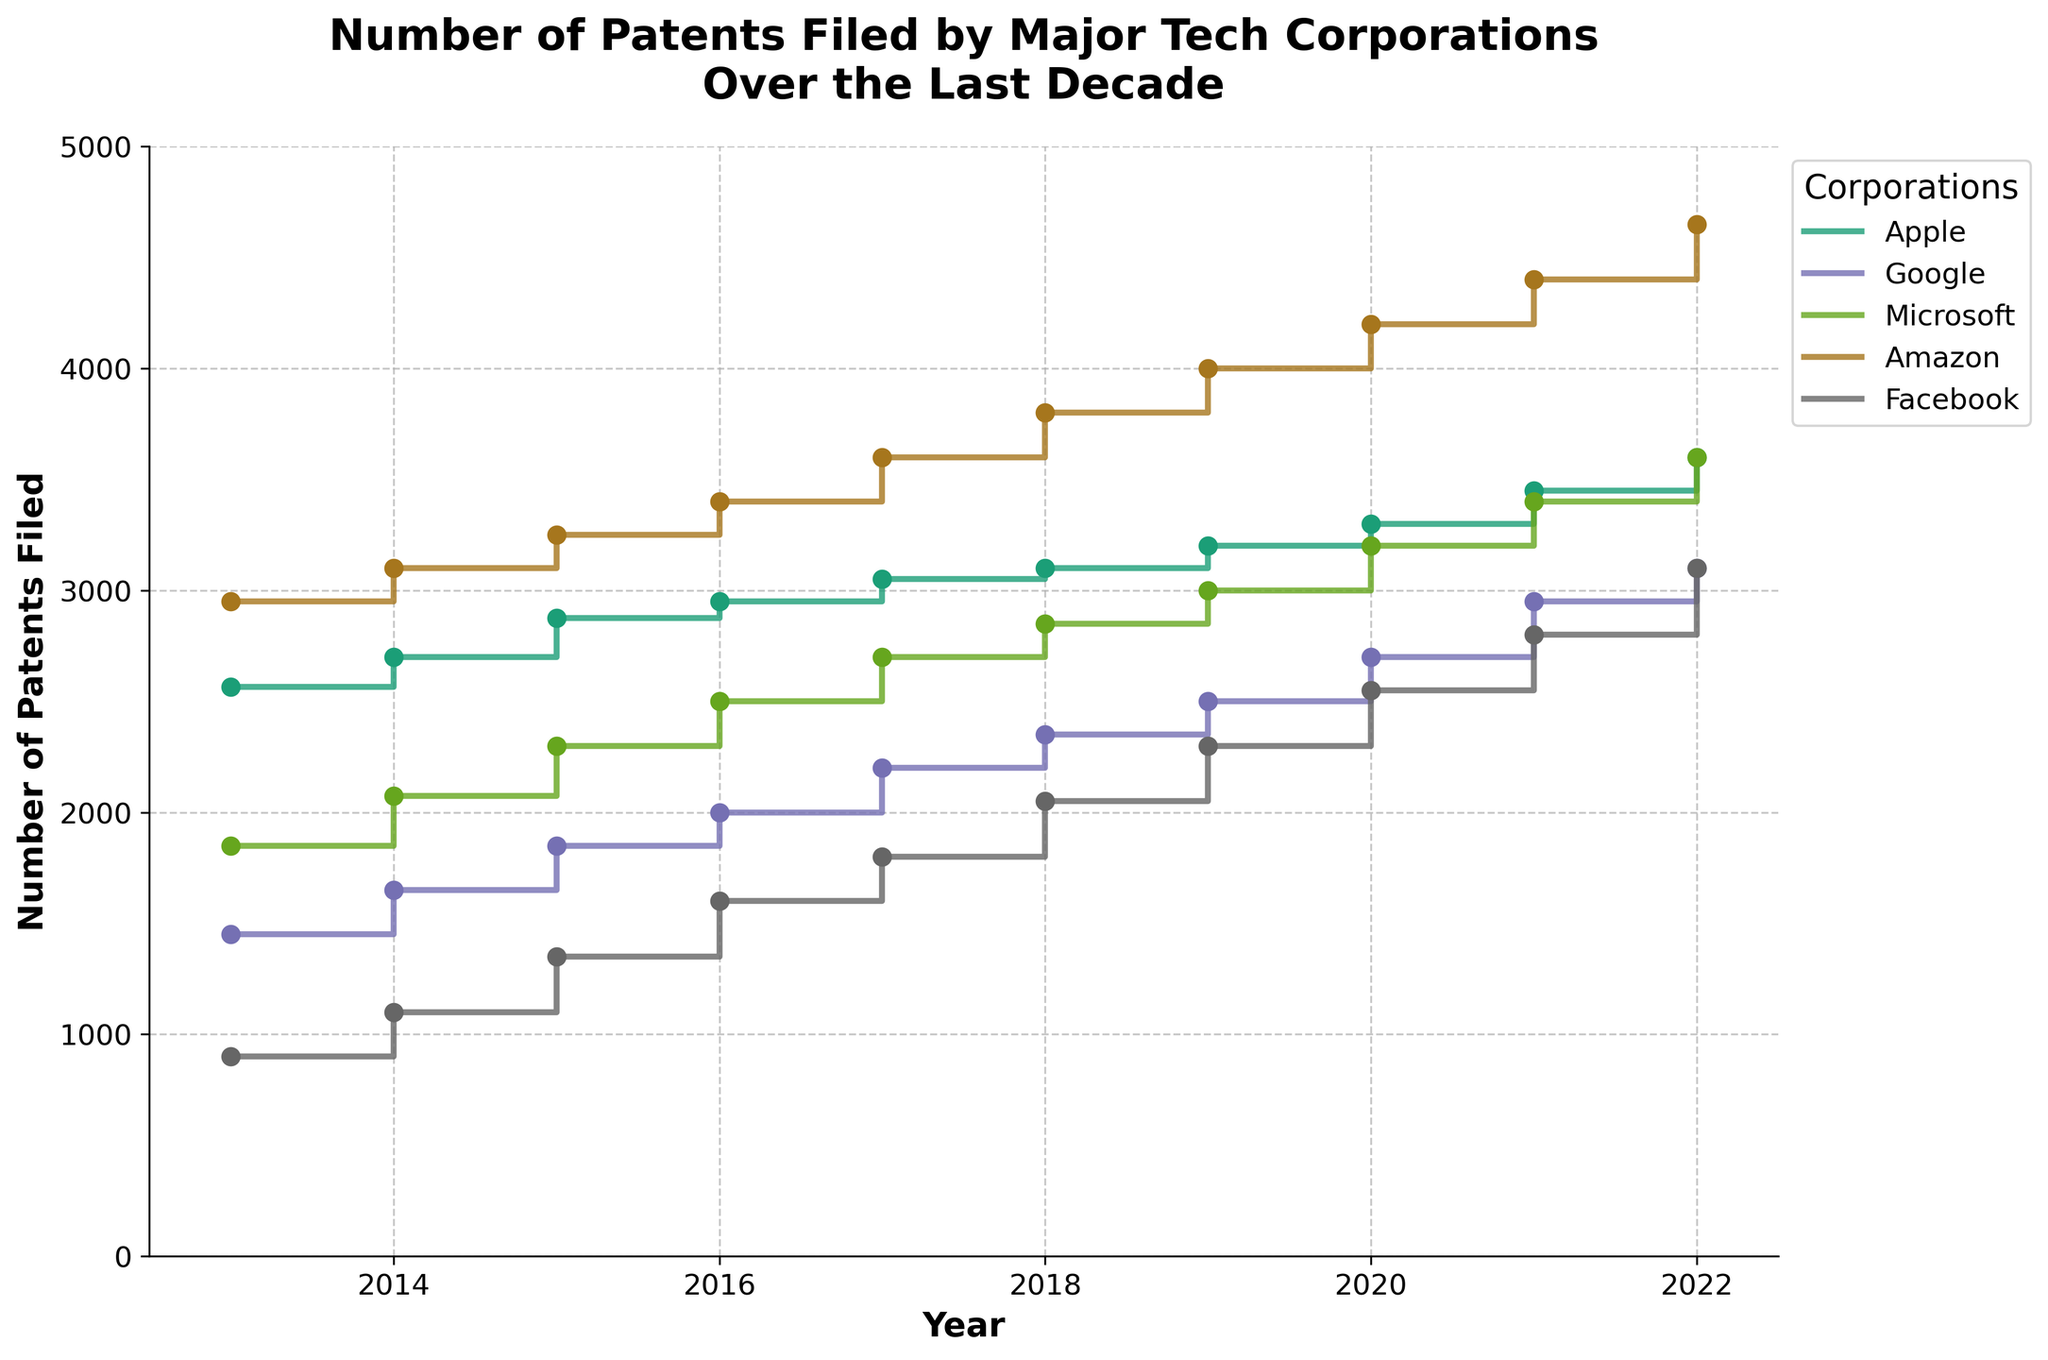What year does the figure start? The figure indicates the patents filed from different corporations starting from the year on the x-axis' lower bound. The axis starts from 2013.
Answer: 2013 Which corporation filed the most patents in 2022? To find this, look at the data points for 2022 and compare the values. Amazon has the highest value at 4650 patents filed.
Answer: Amazon How did the number of patents filed by Facebook change from 2013 to 2022? Check the starting and ending points for Facebook in the plot. Facebook's patents increased from 900 in 2013 to 3100 in 2022.
Answer: Increased Which corporation showed a relatively steady increase in the number of patents filed each year? Look for corporations whose stair steps have relatively uniform height. Google shows a relatively steady increase each year.
Answer: Google In which year did Apple surpass 3000 patents filed? To find when Apple's patents went above 3000, check the y-axis value for the step that first exceeds 3000. This happened in 2017.
Answer: 2017 Who filed more patents in 2015, Microsoft or Google? Compare the values for Microsoft and Google in 2015. Microsoft filed 2300 whereas Google filed 1850.
Answer: Microsoft What is the overall trend for the number of patents filed by Amazon from 2013 to 2022? Observing the stair plot for Amazon, the overall trend shows a continuous increase in patents filed.
Answer: Continuous increase Calculate the total increase in patents filed by Microsoft from 2013 to 2022. Subtract the number of patents filed by Microsoft in 2013 from the number filed in 2022: 3600 - 1850 = 1750.
Answer: 1750 Which corporation has the most significant increase in the number of patents from 2013 to 2022? Calculate the differences from 2013 to 2022 for all corporations. Amazon has the most significant increase: 4650 - 2950 = 1700.
Answer: Amazon Does any corporation have exactly 3100 patents filed in 2022? Check the y-axis value for 2022 across all corporations. Both Google and Facebook have exactly 3100 patents filed in 2022.
Answer: Google and Facebook 